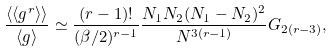Convert formula to latex. <formula><loc_0><loc_0><loc_500><loc_500>\frac { \langle \langle g ^ { r } \rangle \rangle } { \langle g \rangle } \simeq \frac { ( r - 1 ) ! } { ( \beta / 2 ) ^ { r - 1 } } \frac { N _ { 1 } N _ { 2 } ( N _ { 1 } - N _ { 2 } ) ^ { 2 } } { N ^ { 3 ( r - 1 ) } } G _ { 2 ( r - 3 ) } ,</formula> 